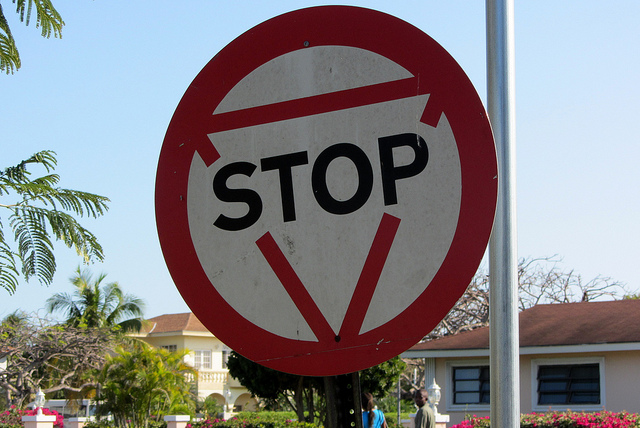Please transcribe the text information in this image. STOP 